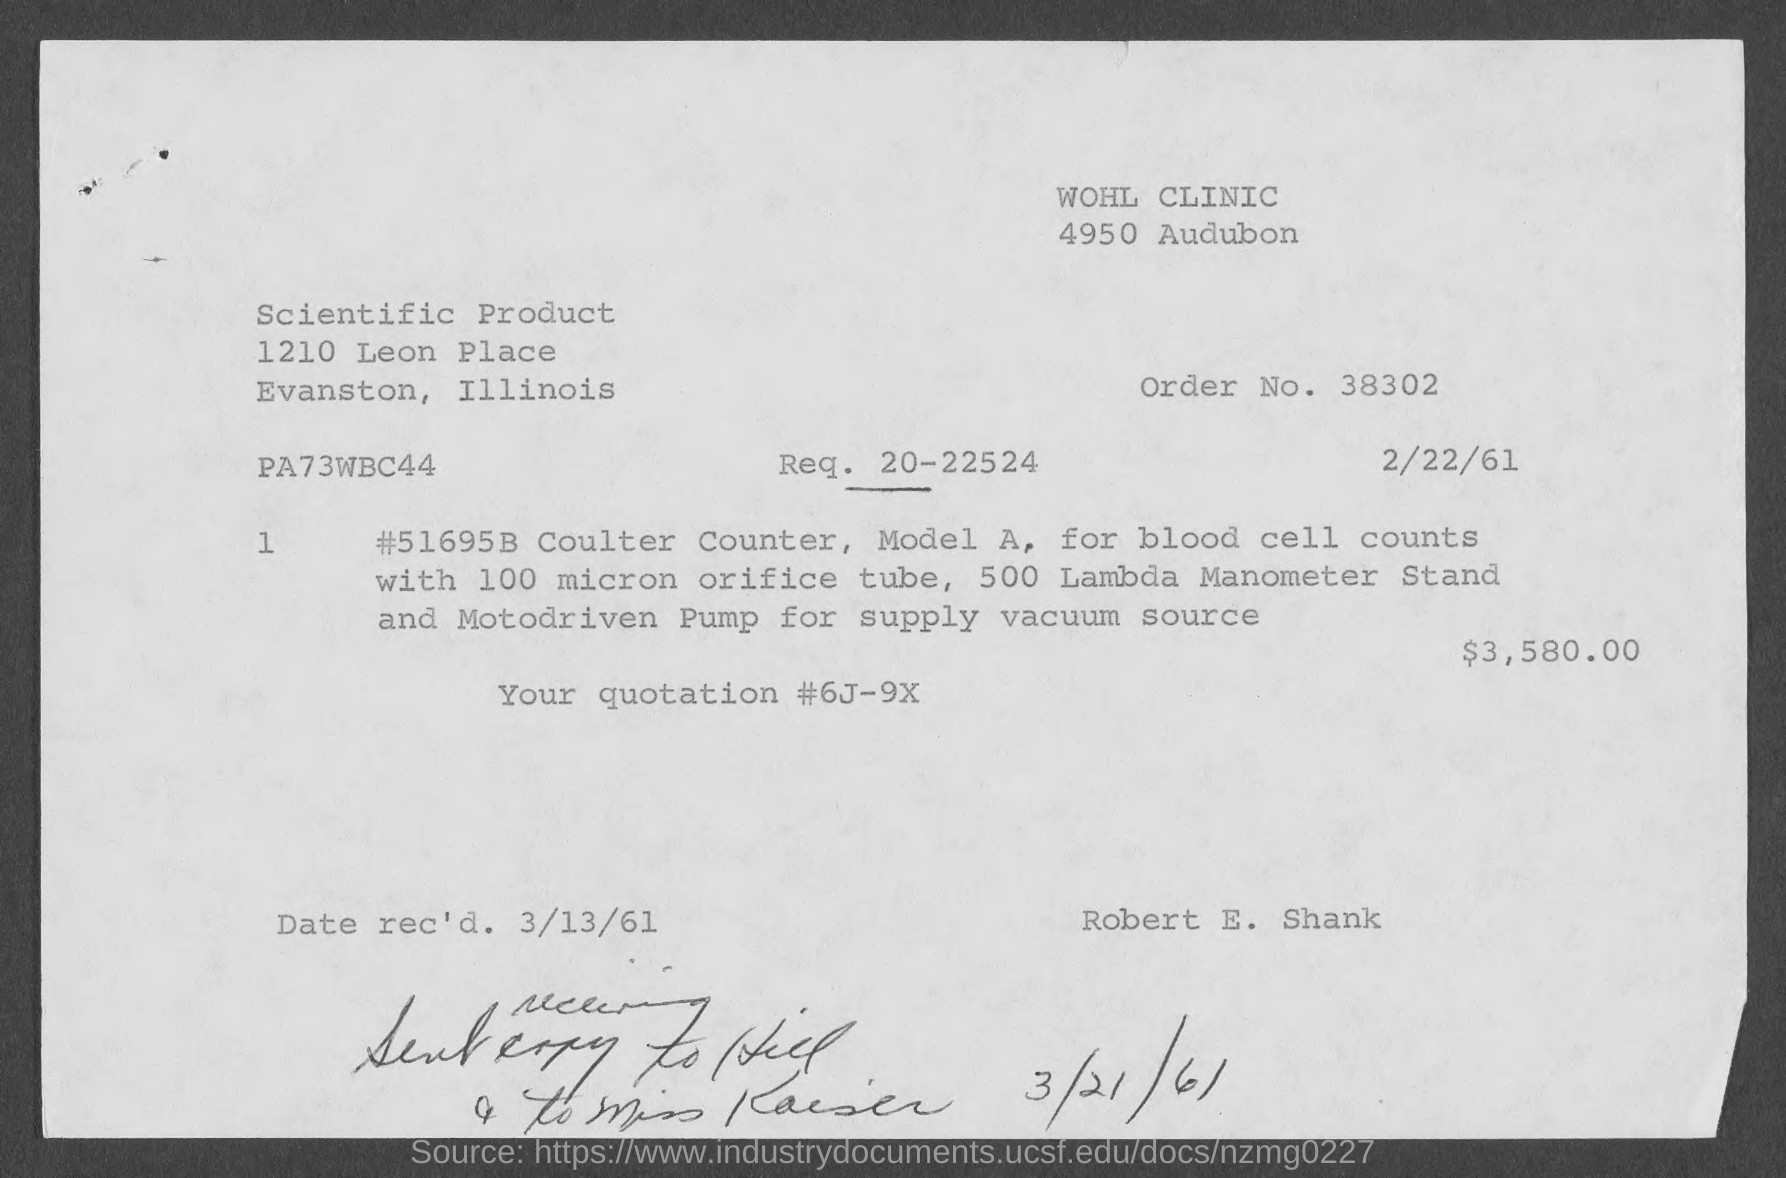Point out several critical features in this image. The order number is 38302, which consists of a sequence of digits. The date of receipt is March 13, 1961. What is request number 20-22524? The amount of the quotation is $3,580.00. 